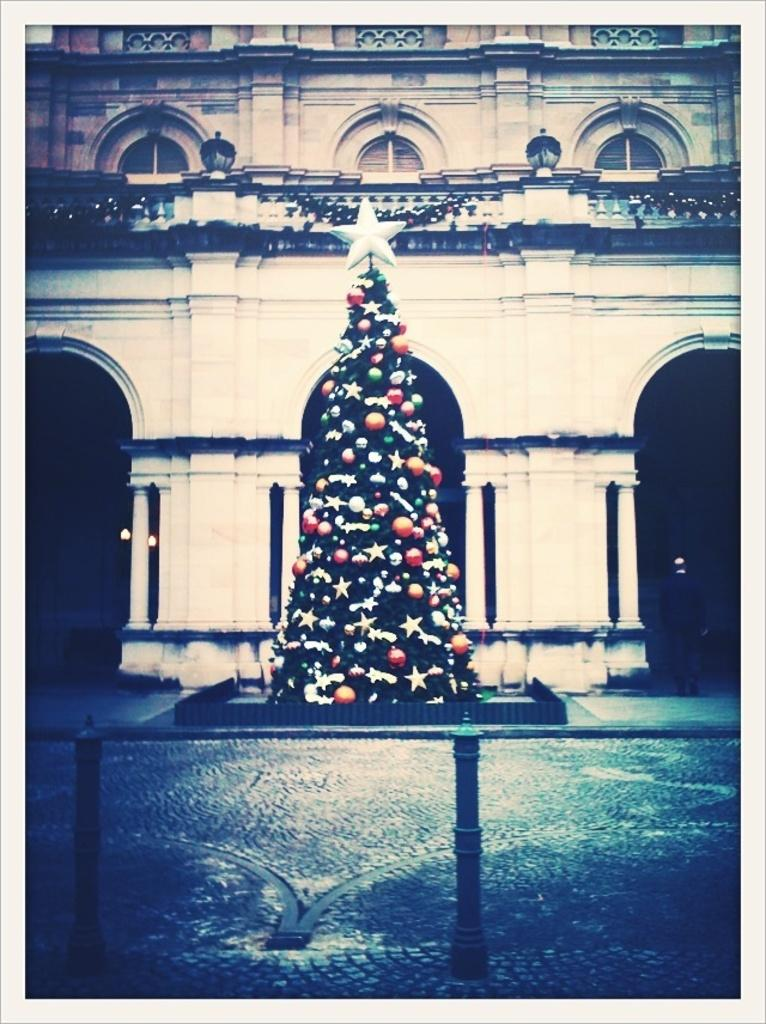What is the main subject of the image? There is a decorated Christmas tree in the image. Where is the Christmas tree located? The Christmas tree is on a table. What is at the top of the Christmas tree? There is a star on the top of the Christmas tree. What can be seen in the background of the image? There is a building visible in the background of the image. How many boots are hanging on the wall behind the Christmas tree? There are no boots visible in the image; the focus is on the decorated Christmas tree and the building in the background. 